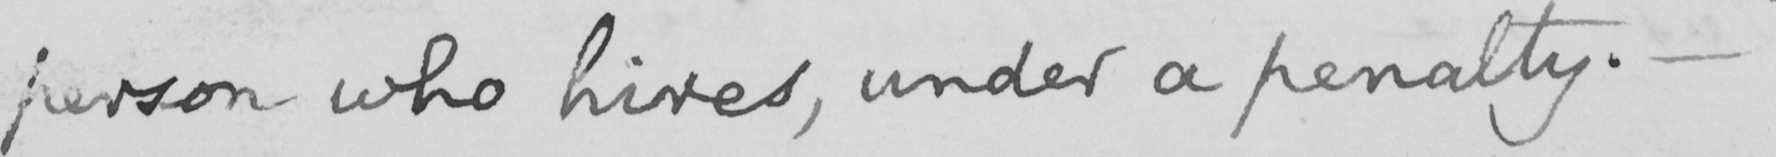Transcribe the text shown in this historical manuscript line. person who hires , under a penalty .  _ 